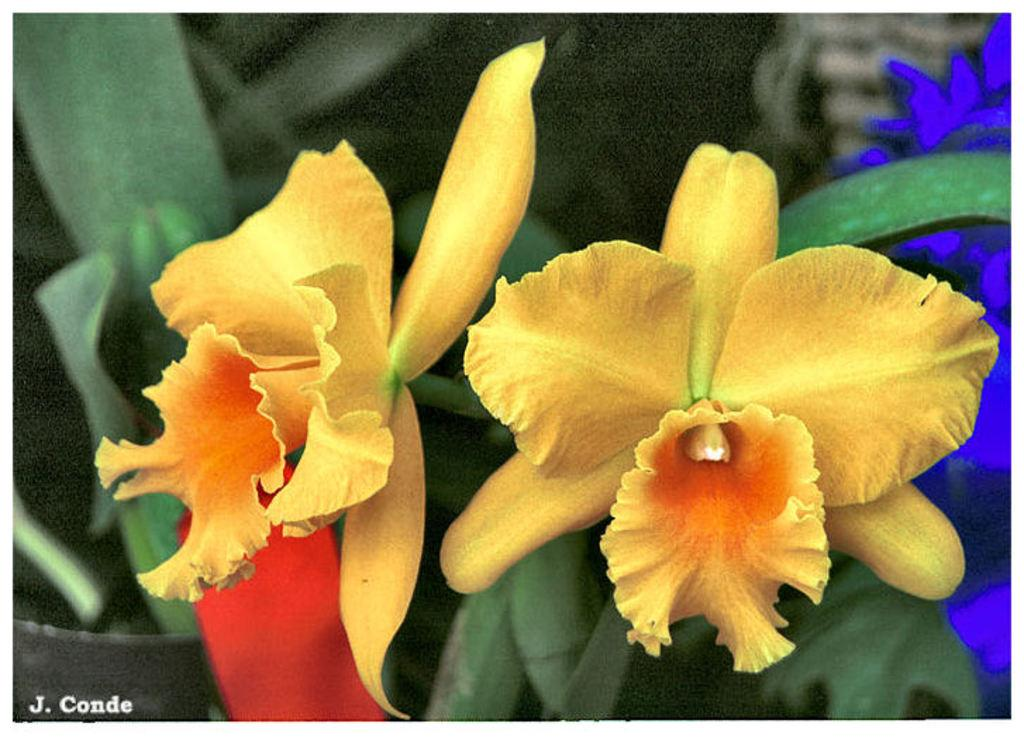What type of living organisms can be seen in the image? There are flowers and plants visible in the image. What is the background of the image like? The background of the image is blurred. Is there any text present in the image? Yes, there is text visible on the image. How many spiders can be seen crawling on the drawer in the image? There is no drawer or spiders present in the image; it features flowers and plants with a blurred background and visible text. 